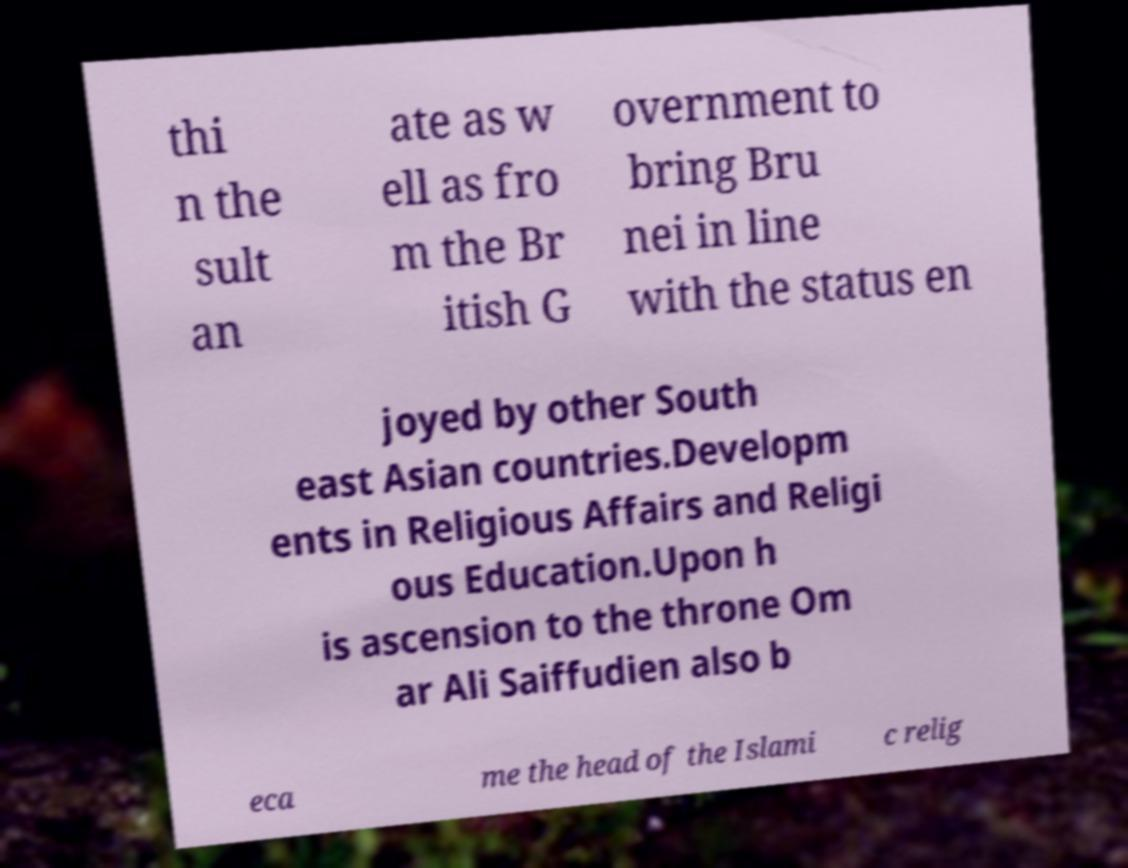Can you read and provide the text displayed in the image?This photo seems to have some interesting text. Can you extract and type it out for me? thi n the sult an ate as w ell as fro m the Br itish G overnment to bring Bru nei in line with the status en joyed by other South east Asian countries.Developm ents in Religious Affairs and Religi ous Education.Upon h is ascension to the throne Om ar Ali Saiffudien also b eca me the head of the Islami c relig 